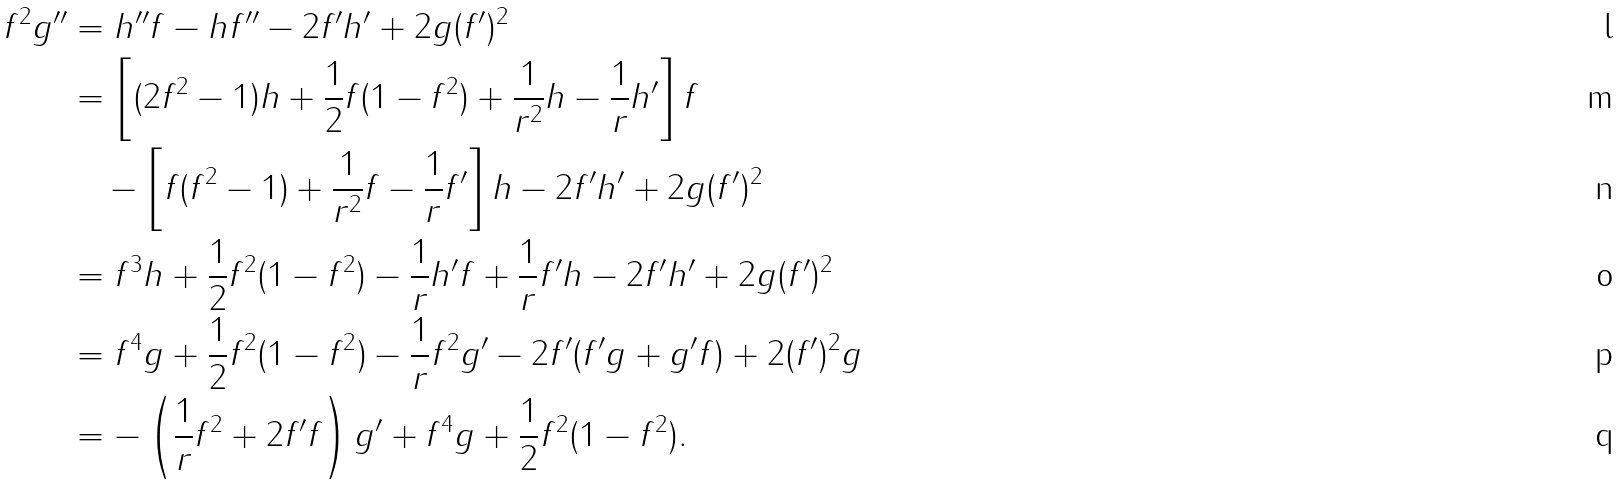Convert formula to latex. <formula><loc_0><loc_0><loc_500><loc_500>f ^ { 2 } g ^ { \prime \prime } & = h ^ { \prime \prime } f - h f ^ { \prime \prime } - 2 f ^ { \prime } h ^ { \prime } + 2 g ( f ^ { \prime } ) ^ { 2 } \\ & = \left [ ( 2 f ^ { 2 } - 1 ) h + \frac { 1 } { 2 } f ( 1 - f ^ { 2 } ) + \frac { 1 } { r ^ { 2 } } h - \frac { 1 } { r } h ^ { \prime } \right ] f \\ & \quad - \left [ f ( f ^ { 2 } - 1 ) + \frac { 1 } { r ^ { 2 } } f - \frac { 1 } { r } f ^ { \prime } \right ] h - 2 f ^ { \prime } h ^ { \prime } + 2 g ( f ^ { \prime } ) ^ { 2 } \\ & = f ^ { 3 } h + \frac { 1 } { 2 } f ^ { 2 } ( 1 - f ^ { 2 } ) - \frac { 1 } { r } h ^ { \prime } f + \frac { 1 } { r } f ^ { \prime } h - 2 f ^ { \prime } h ^ { \prime } + 2 g ( f ^ { \prime } ) ^ { 2 } \\ & = f ^ { 4 } g + \frac { 1 } { 2 } f ^ { 2 } ( 1 - f ^ { 2 } ) - \frac { 1 } { r } f ^ { 2 } g ^ { \prime } - 2 f ^ { \prime } ( f ^ { \prime } g + g ^ { \prime } f ) + 2 ( f ^ { \prime } ) ^ { 2 } g \\ & = - \left ( \frac { 1 } { r } f ^ { 2 } + 2 f ^ { \prime } f \right ) g ^ { \prime } + f ^ { 4 } g + \frac { 1 } { 2 } f ^ { 2 } ( 1 - f ^ { 2 } ) .</formula> 